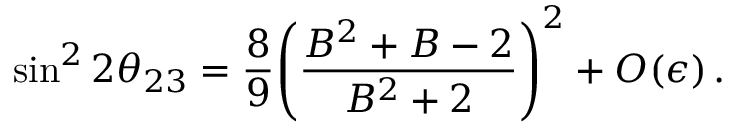<formula> <loc_0><loc_0><loc_500><loc_500>\sin ^ { 2 } 2 \theta _ { 2 3 } = \frac { 8 } { 9 } { \left ( \frac { B ^ { 2 } + B - 2 } { B ^ { 2 } + 2 } \right ) } ^ { 2 } + O ( \epsilon ) \, .</formula> 